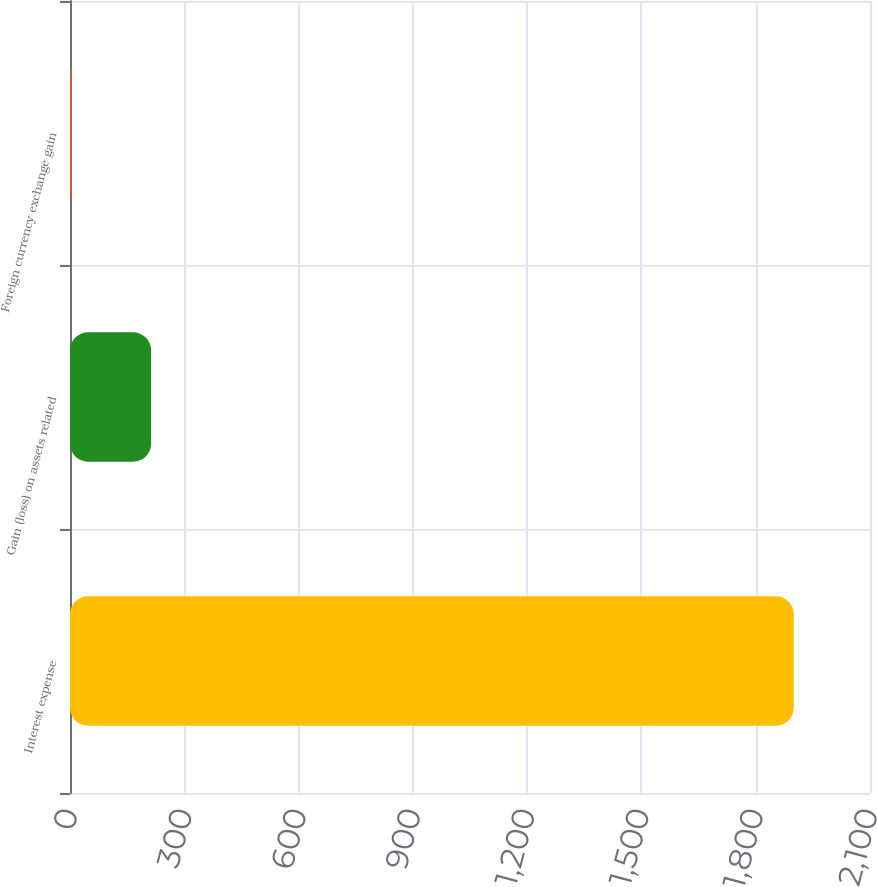<chart> <loc_0><loc_0><loc_500><loc_500><bar_chart><fcel>Interest expense<fcel>Gain (loss) on assets related<fcel>Foreign currency exchange gain<nl><fcel>1900<fcel>213<fcel>3.93<nl></chart> 